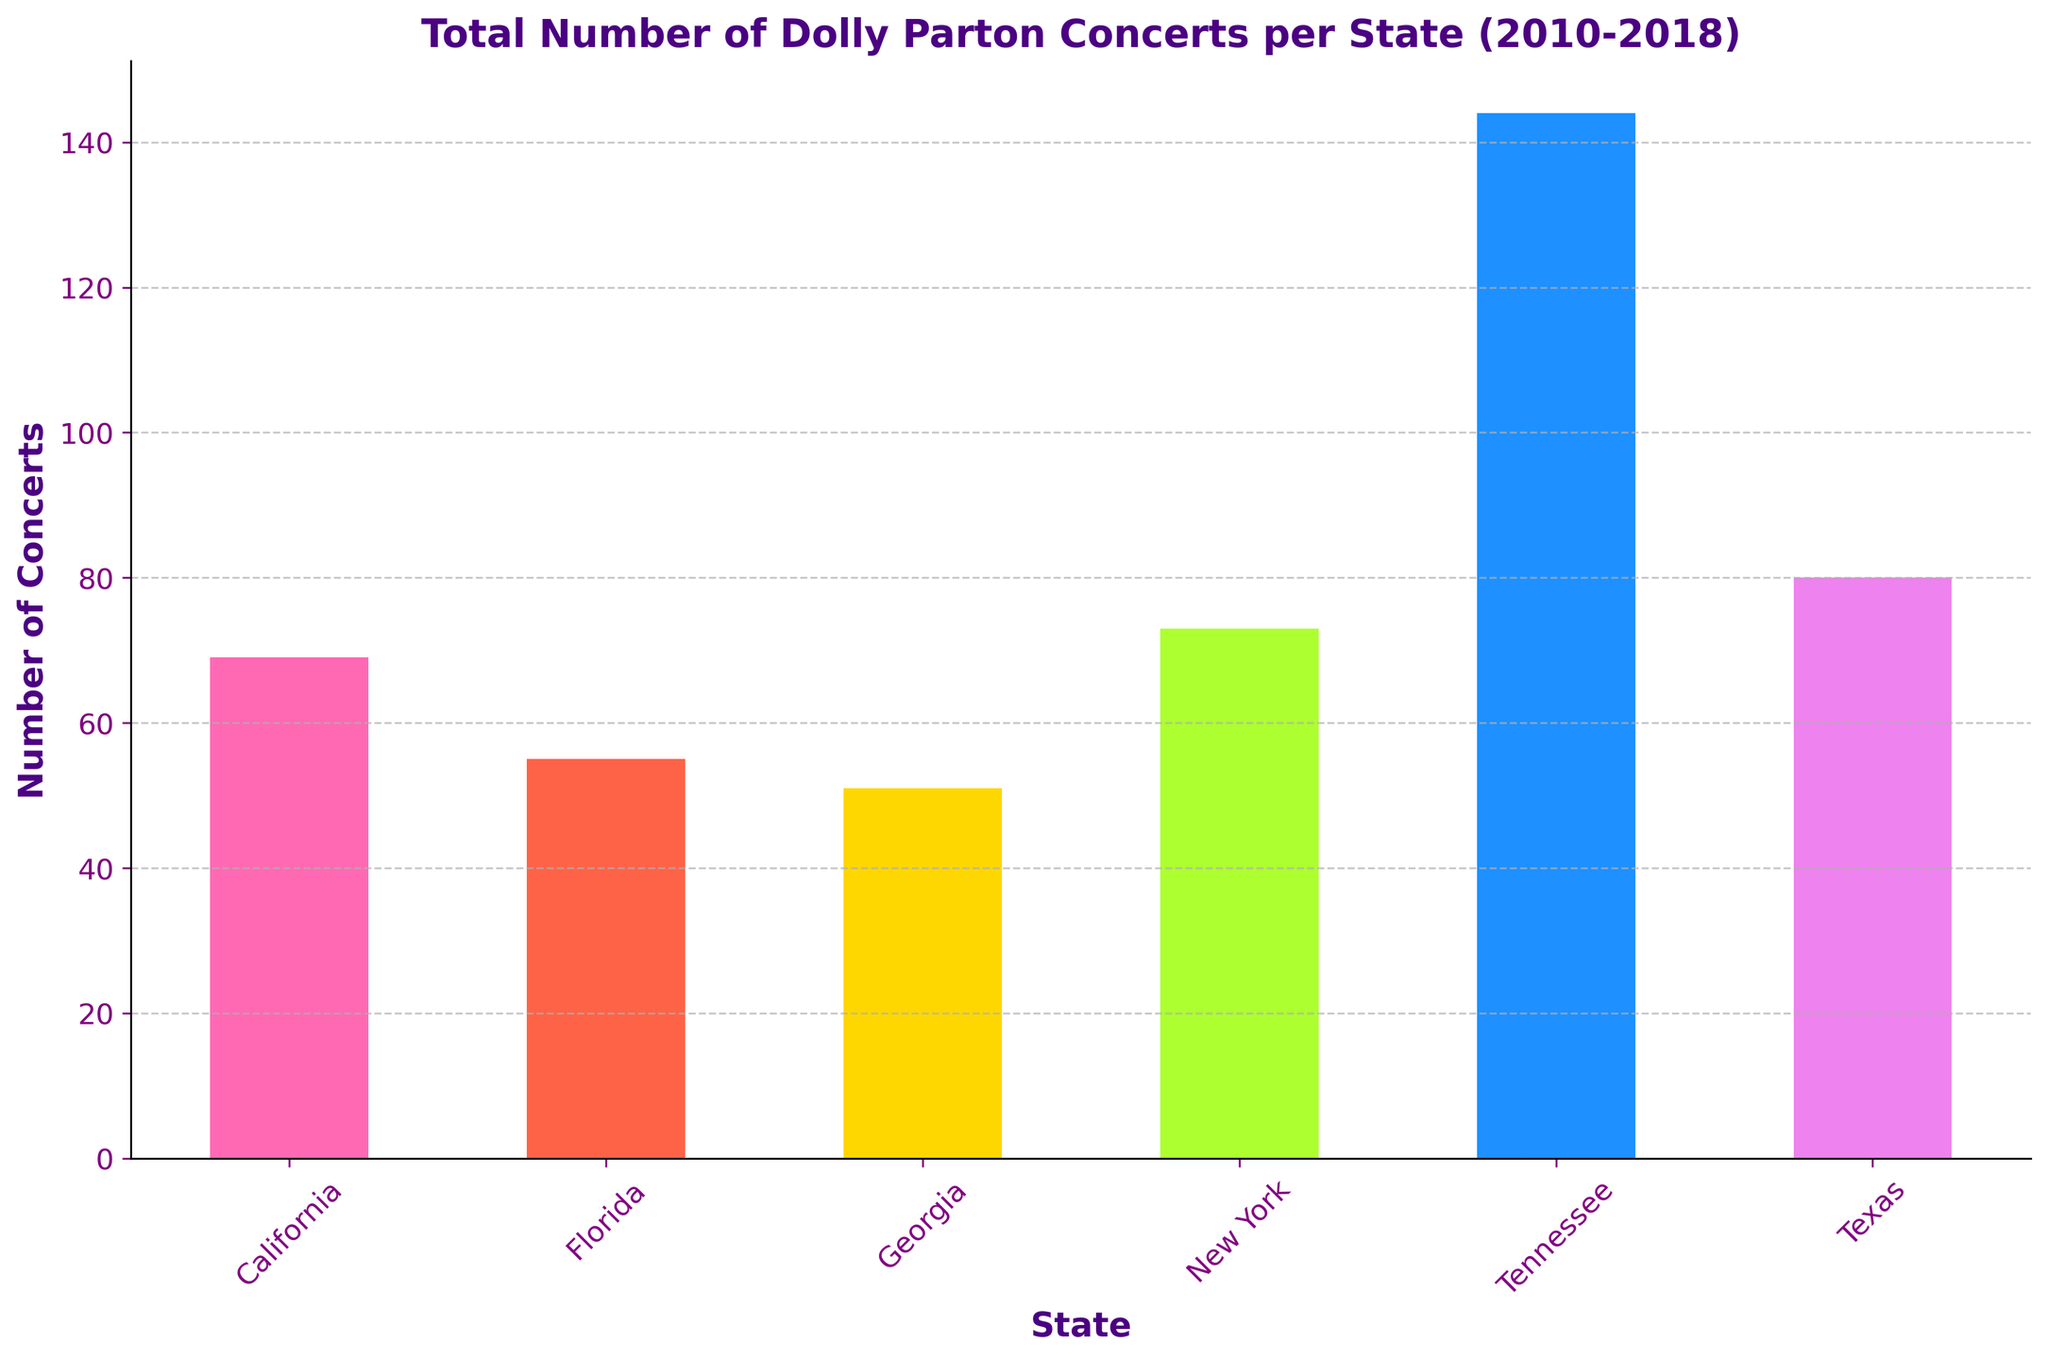Which state had the highest total number of Dolly Parton concerts from 2010 to 2018? The tallest bar on the plot represents the state with the highest total number of concerts. By visually checking, Tennessee has the tallest bar.
Answer: Tennessee Which state had the lowest total number of Dolly Parton concerts from 2010 to 2018? The shortest bar on the plot represents the state with the lowest total number of concerts. By visually checking, Georgia has the shortest bar.
Answer: Georgia How many concerts were held in Tennessee in total from 2010 to 2018? The height of the bar for Tennessee indicates the total number of concerts. Sum the numbers: 12 + 15 + 10 + 18 + 14 + 20 + 17 + 22 + 16 = 144
Answer: 144 Compare the total number of concerts held in California and New York from 2010 to 2018. Look at the heights of the bars for California and New York. California's bar height indicates 59 concerts, and New York's bar height indicates 63 concerts.
Answer: New York had more concerts What's the average number of concerts held per state from 2010 to 2018? Sum the total number of concerts for all states and divide by the number of states. Total = 144 + 59 + 70 + 63 + 51 + 55 = 442. Number of states = 6. Average = 442 / 6 ≈ 73.67
Answer: 73.67 Which state had more concerts: Texas or Florida? Compare the heights of the bars for Texas and Florida. Texas has a taller bar indicating more concerts than Florida.
Answer: Texas Is there a significant difference in the number of concerts between Georgia and Florida? By comparing the heights of the bars, Georgia (shorter) had 51 concerts and Florida (taller) had 55 concerts. The difference is not significant.
Answer: No How do the number of concerts in California in 2010 compare to those in 2018? Check the bar heights for each year and each state. California had 5 concerts in 2010 and 11 in 2018.
Answer: 2018 had more concerts What is the combined total of concerts held in the two states with the fewest and most concerts? Tennessee has the most with 144 concerts and Georgia has the fewest with 51 concerts. Combined total = 144 + 51 = 195
Answer: 195 How many more concerts were held in New York compared to Georgia from 2010 to 2018? Subtract the total number of concerts in Georgia from New York. New York = 63, Georgia = 51. Difference = 63 - 51 = 12
Answer: 12 